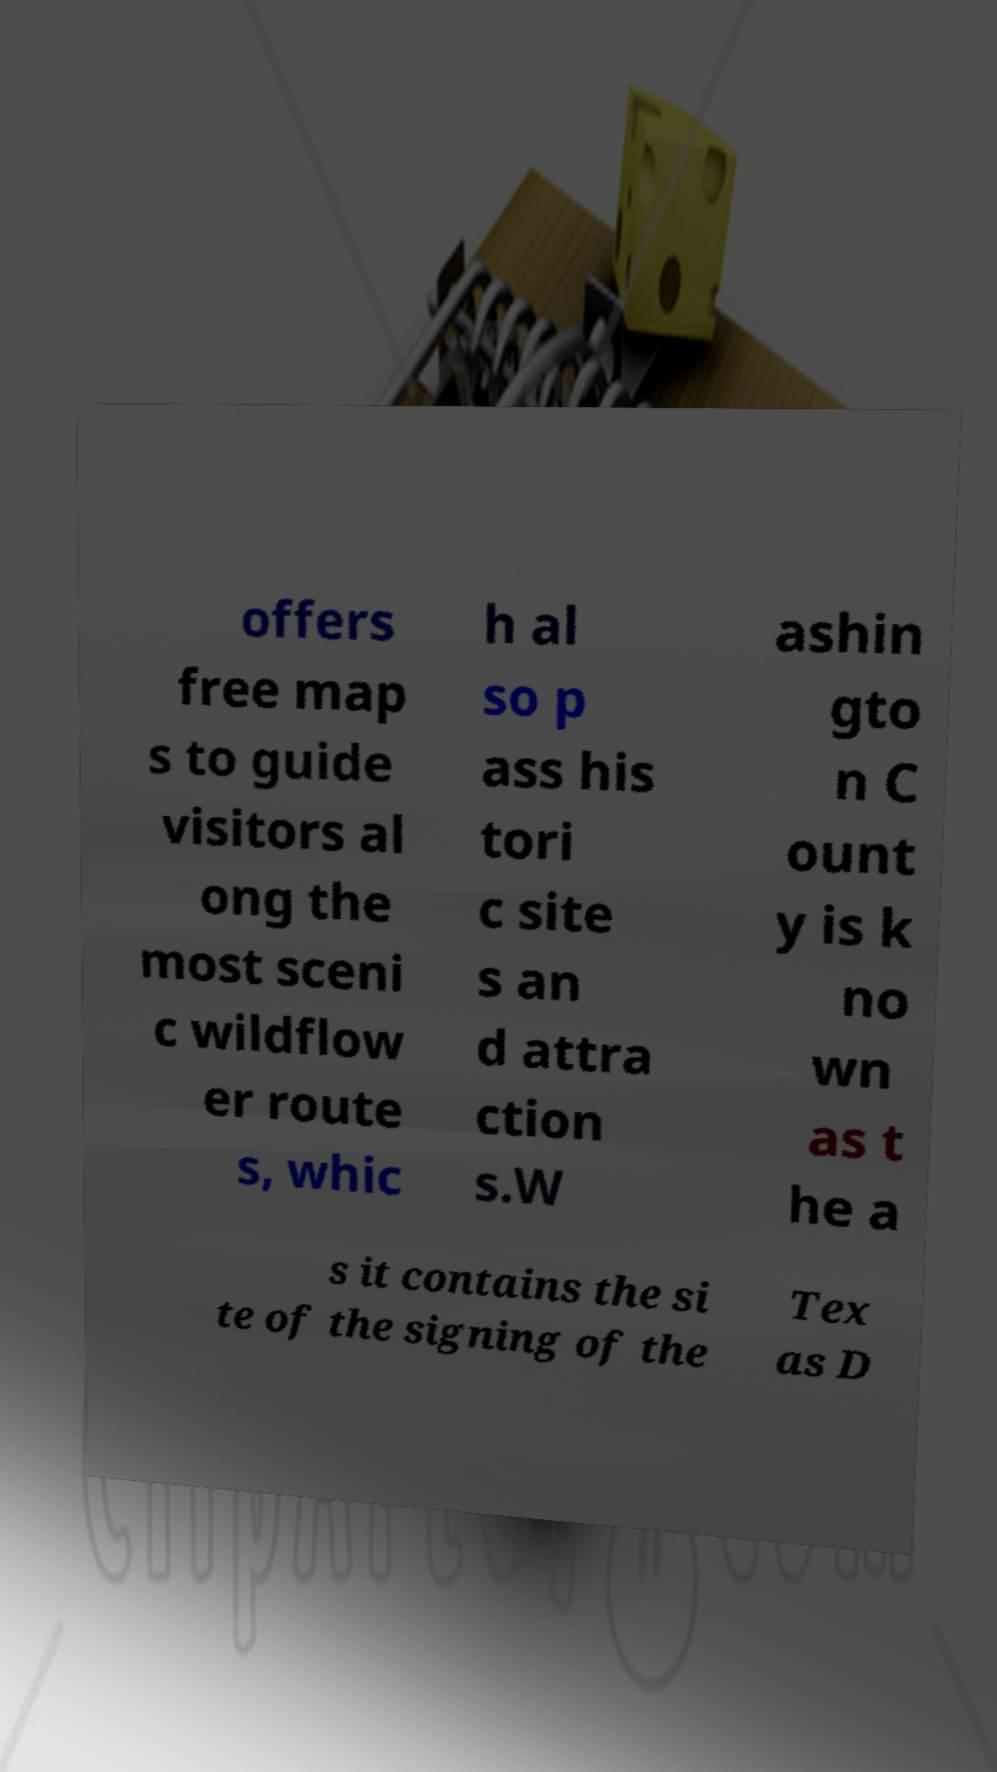Could you extract and type out the text from this image? offers free map s to guide visitors al ong the most sceni c wildflow er route s, whic h al so p ass his tori c site s an d attra ction s.W ashin gto n C ount y is k no wn as t he a s it contains the si te of the signing of the Tex as D 